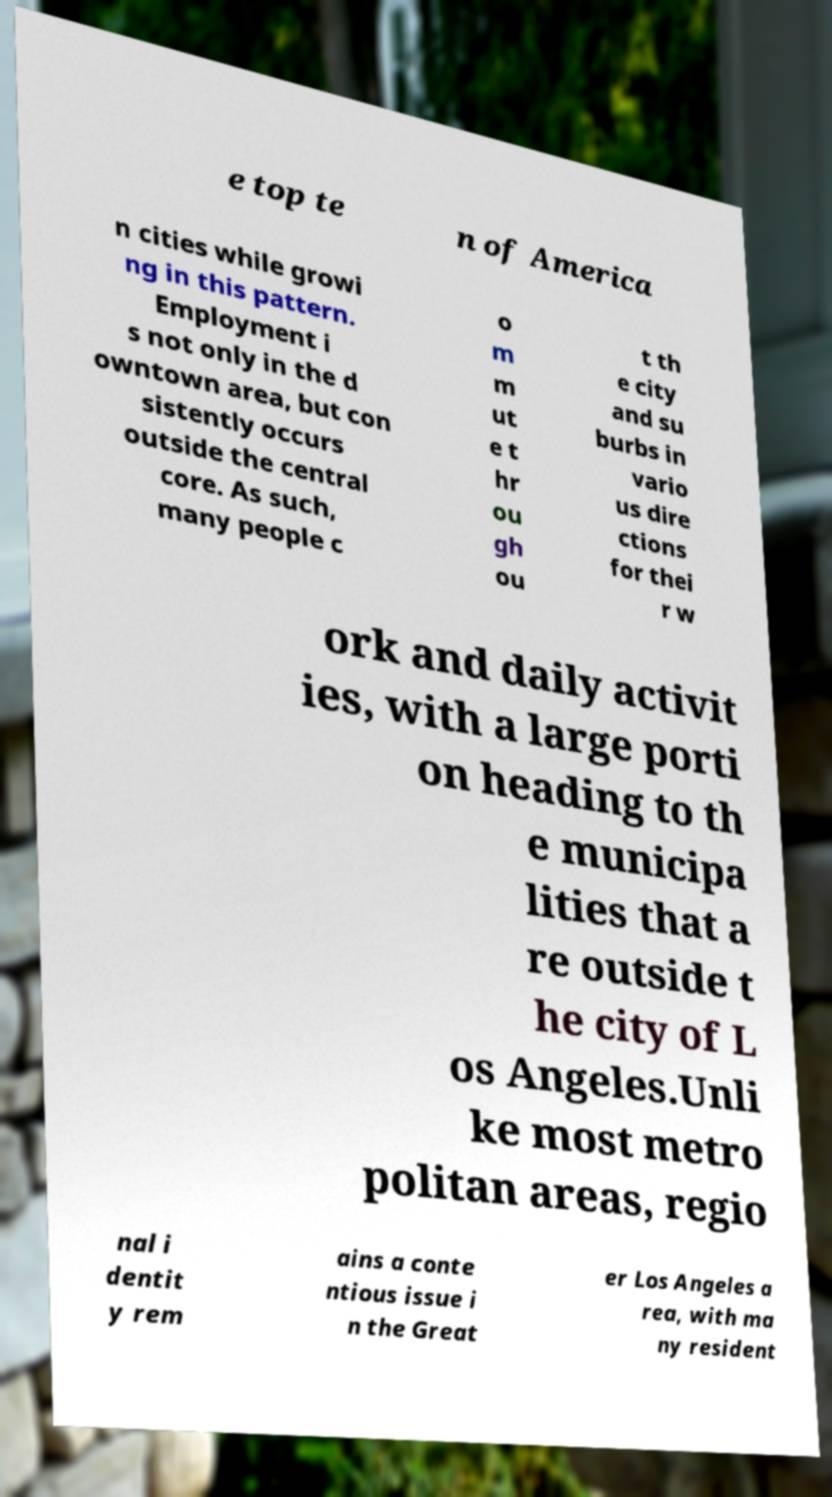Could you extract and type out the text from this image? e top te n of America n cities while growi ng in this pattern. Employment i s not only in the d owntown area, but con sistently occurs outside the central core. As such, many people c o m m ut e t hr ou gh ou t th e city and su burbs in vario us dire ctions for thei r w ork and daily activit ies, with a large porti on heading to th e municipa lities that a re outside t he city of L os Angeles.Unli ke most metro politan areas, regio nal i dentit y rem ains a conte ntious issue i n the Great er Los Angeles a rea, with ma ny resident 